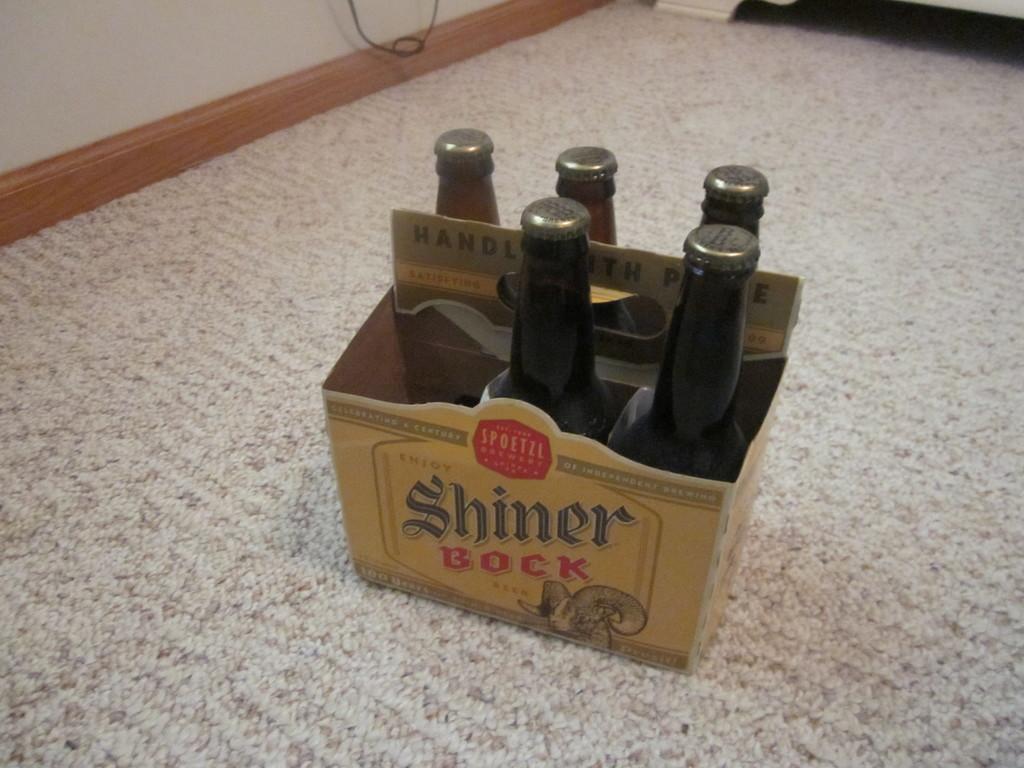What kind of beer is this?
Your answer should be compact. Shiner bock. 